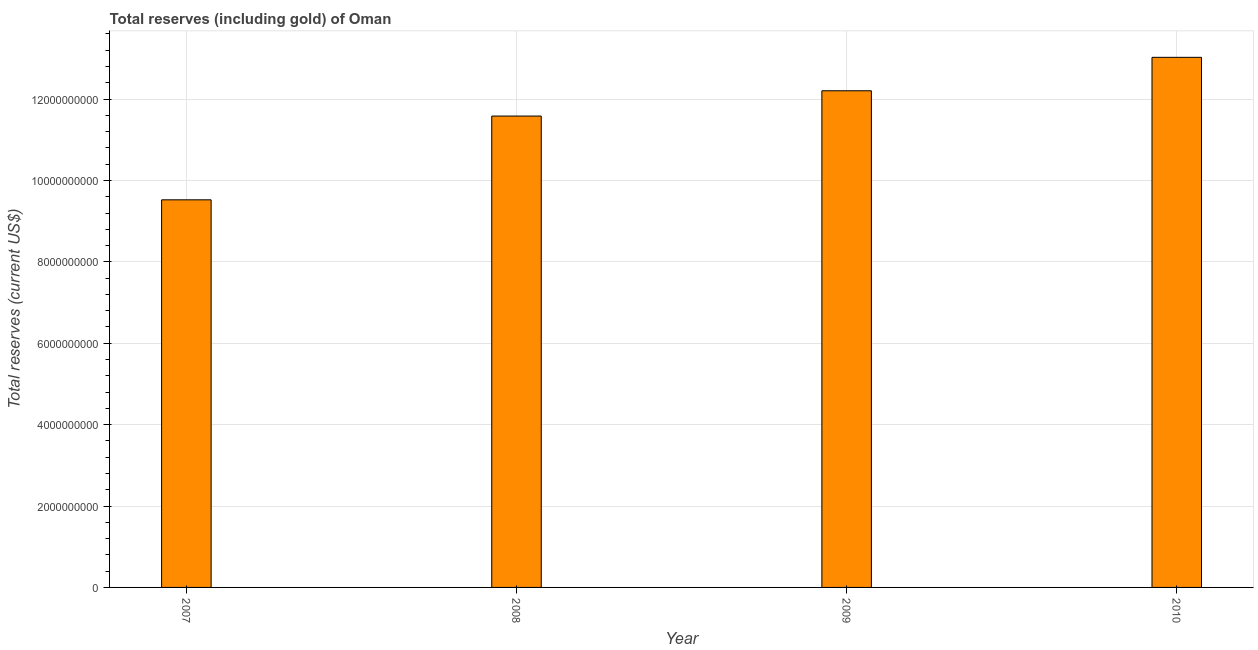What is the title of the graph?
Offer a very short reply. Total reserves (including gold) of Oman. What is the label or title of the Y-axis?
Your response must be concise. Total reserves (current US$). What is the total reserves (including gold) in 2010?
Your response must be concise. 1.30e+1. Across all years, what is the maximum total reserves (including gold)?
Keep it short and to the point. 1.30e+1. Across all years, what is the minimum total reserves (including gold)?
Your answer should be very brief. 9.52e+09. In which year was the total reserves (including gold) maximum?
Your response must be concise. 2010. In which year was the total reserves (including gold) minimum?
Your answer should be compact. 2007. What is the sum of the total reserves (including gold)?
Provide a short and direct response. 4.63e+1. What is the difference between the total reserves (including gold) in 2007 and 2009?
Make the answer very short. -2.68e+09. What is the average total reserves (including gold) per year?
Your answer should be compact. 1.16e+1. What is the median total reserves (including gold)?
Offer a terse response. 1.19e+1. What is the ratio of the total reserves (including gold) in 2008 to that in 2010?
Provide a succinct answer. 0.89. What is the difference between the highest and the second highest total reserves (including gold)?
Provide a succinct answer. 8.22e+08. What is the difference between the highest and the lowest total reserves (including gold)?
Keep it short and to the point. 3.50e+09. How many bars are there?
Keep it short and to the point. 4. What is the difference between two consecutive major ticks on the Y-axis?
Provide a short and direct response. 2.00e+09. Are the values on the major ticks of Y-axis written in scientific E-notation?
Make the answer very short. No. What is the Total reserves (current US$) of 2007?
Ensure brevity in your answer.  9.52e+09. What is the Total reserves (current US$) in 2008?
Your response must be concise. 1.16e+1. What is the Total reserves (current US$) of 2009?
Offer a terse response. 1.22e+1. What is the Total reserves (current US$) of 2010?
Your answer should be compact. 1.30e+1. What is the difference between the Total reserves (current US$) in 2007 and 2008?
Your response must be concise. -2.06e+09. What is the difference between the Total reserves (current US$) in 2007 and 2009?
Your response must be concise. -2.68e+09. What is the difference between the Total reserves (current US$) in 2007 and 2010?
Provide a succinct answer. -3.50e+09. What is the difference between the Total reserves (current US$) in 2008 and 2009?
Provide a short and direct response. -6.21e+08. What is the difference between the Total reserves (current US$) in 2008 and 2010?
Keep it short and to the point. -1.44e+09. What is the difference between the Total reserves (current US$) in 2009 and 2010?
Your answer should be very brief. -8.22e+08. What is the ratio of the Total reserves (current US$) in 2007 to that in 2008?
Offer a very short reply. 0.82. What is the ratio of the Total reserves (current US$) in 2007 to that in 2009?
Keep it short and to the point. 0.78. What is the ratio of the Total reserves (current US$) in 2007 to that in 2010?
Keep it short and to the point. 0.73. What is the ratio of the Total reserves (current US$) in 2008 to that in 2009?
Your response must be concise. 0.95. What is the ratio of the Total reserves (current US$) in 2008 to that in 2010?
Offer a very short reply. 0.89. What is the ratio of the Total reserves (current US$) in 2009 to that in 2010?
Ensure brevity in your answer.  0.94. 